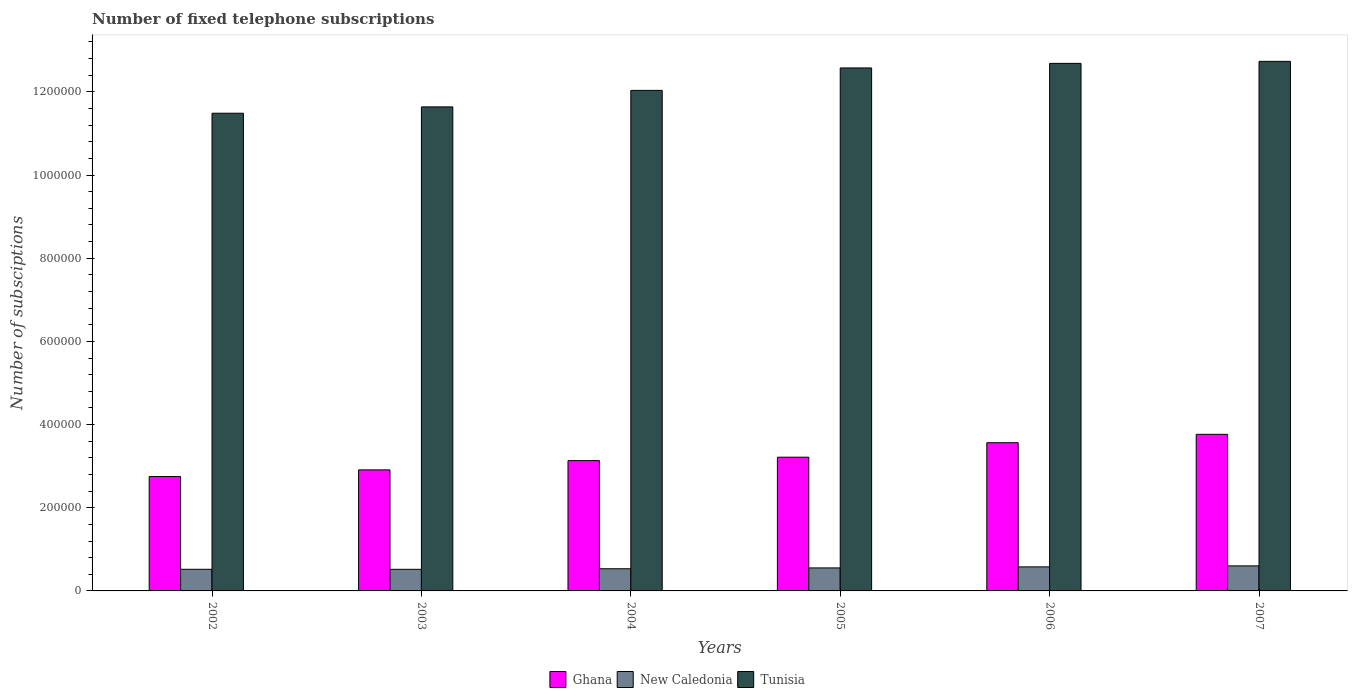How many different coloured bars are there?
Offer a very short reply. 3. Are the number of bars per tick equal to the number of legend labels?
Provide a short and direct response. Yes. How many bars are there on the 6th tick from the left?
Offer a terse response. 3. How many bars are there on the 6th tick from the right?
Your answer should be very brief. 3. What is the number of fixed telephone subscriptions in Ghana in 2003?
Your answer should be very brief. 2.91e+05. Across all years, what is the maximum number of fixed telephone subscriptions in New Caledonia?
Keep it short and to the point. 6.02e+04. Across all years, what is the minimum number of fixed telephone subscriptions in Ghana?
Provide a short and direct response. 2.75e+05. In which year was the number of fixed telephone subscriptions in New Caledonia maximum?
Your answer should be compact. 2007. What is the total number of fixed telephone subscriptions in New Caledonia in the graph?
Your answer should be compact. 3.31e+05. What is the difference between the number of fixed telephone subscriptions in New Caledonia in 2002 and that in 2005?
Offer a very short reply. -3310. What is the difference between the number of fixed telephone subscriptions in New Caledonia in 2003 and the number of fixed telephone subscriptions in Tunisia in 2002?
Provide a short and direct response. -1.10e+06. What is the average number of fixed telephone subscriptions in New Caledonia per year?
Your answer should be very brief. 5.51e+04. In the year 2005, what is the difference between the number of fixed telephone subscriptions in Tunisia and number of fixed telephone subscriptions in New Caledonia?
Make the answer very short. 1.20e+06. What is the ratio of the number of fixed telephone subscriptions in Tunisia in 2005 to that in 2006?
Give a very brief answer. 0.99. Is the difference between the number of fixed telephone subscriptions in Tunisia in 2004 and 2006 greater than the difference between the number of fixed telephone subscriptions in New Caledonia in 2004 and 2006?
Make the answer very short. No. What is the difference between the highest and the second highest number of fixed telephone subscriptions in New Caledonia?
Your answer should be compact. 2409. What is the difference between the highest and the lowest number of fixed telephone subscriptions in New Caledonia?
Provide a succinct answer. 8281. In how many years, is the number of fixed telephone subscriptions in New Caledonia greater than the average number of fixed telephone subscriptions in New Caledonia taken over all years?
Ensure brevity in your answer.  3. What does the 2nd bar from the right in 2007 represents?
Provide a succinct answer. New Caledonia. Is it the case that in every year, the sum of the number of fixed telephone subscriptions in Tunisia and number of fixed telephone subscriptions in Ghana is greater than the number of fixed telephone subscriptions in New Caledonia?
Your answer should be very brief. Yes. Are all the bars in the graph horizontal?
Provide a short and direct response. No. How are the legend labels stacked?
Give a very brief answer. Horizontal. What is the title of the graph?
Offer a very short reply. Number of fixed telephone subscriptions. Does "Iran" appear as one of the legend labels in the graph?
Offer a very short reply. No. What is the label or title of the Y-axis?
Offer a very short reply. Number of subsciptions. What is the Number of subsciptions in Ghana in 2002?
Your answer should be compact. 2.75e+05. What is the Number of subsciptions of New Caledonia in 2002?
Offer a terse response. 5.20e+04. What is the Number of subsciptions in Tunisia in 2002?
Keep it short and to the point. 1.15e+06. What is the Number of subsciptions of Ghana in 2003?
Give a very brief answer. 2.91e+05. What is the Number of subsciptions of New Caledonia in 2003?
Provide a succinct answer. 5.19e+04. What is the Number of subsciptions of Tunisia in 2003?
Provide a succinct answer. 1.16e+06. What is the Number of subsciptions in Ghana in 2004?
Ensure brevity in your answer.  3.13e+05. What is the Number of subsciptions in New Caledonia in 2004?
Your answer should be compact. 5.33e+04. What is the Number of subsciptions in Tunisia in 2004?
Your response must be concise. 1.20e+06. What is the Number of subsciptions of Ghana in 2005?
Keep it short and to the point. 3.22e+05. What is the Number of subsciptions of New Caledonia in 2005?
Ensure brevity in your answer.  5.53e+04. What is the Number of subsciptions of Tunisia in 2005?
Offer a very short reply. 1.26e+06. What is the Number of subsciptions of Ghana in 2006?
Provide a short and direct response. 3.56e+05. What is the Number of subsciptions in New Caledonia in 2006?
Provide a short and direct response. 5.78e+04. What is the Number of subsciptions of Tunisia in 2006?
Your response must be concise. 1.27e+06. What is the Number of subsciptions in Ghana in 2007?
Your answer should be very brief. 3.77e+05. What is the Number of subsciptions of New Caledonia in 2007?
Your answer should be compact. 6.02e+04. What is the Number of subsciptions in Tunisia in 2007?
Make the answer very short. 1.27e+06. Across all years, what is the maximum Number of subsciptions of Ghana?
Offer a terse response. 3.77e+05. Across all years, what is the maximum Number of subsciptions of New Caledonia?
Provide a short and direct response. 6.02e+04. Across all years, what is the maximum Number of subsciptions of Tunisia?
Offer a terse response. 1.27e+06. Across all years, what is the minimum Number of subsciptions of Ghana?
Make the answer very short. 2.75e+05. Across all years, what is the minimum Number of subsciptions in New Caledonia?
Offer a very short reply. 5.19e+04. Across all years, what is the minimum Number of subsciptions of Tunisia?
Offer a terse response. 1.15e+06. What is the total Number of subsciptions in Ghana in the graph?
Your response must be concise. 1.93e+06. What is the total Number of subsciptions of New Caledonia in the graph?
Offer a terse response. 3.31e+05. What is the total Number of subsciptions of Tunisia in the graph?
Offer a terse response. 7.32e+06. What is the difference between the Number of subsciptions of Ghana in 2002 and that in 2003?
Offer a terse response. -1.60e+04. What is the difference between the Number of subsciptions of New Caledonia in 2002 and that in 2003?
Offer a very short reply. 72. What is the difference between the Number of subsciptions of Tunisia in 2002 and that in 2003?
Offer a terse response. -1.53e+04. What is the difference between the Number of subsciptions of Ghana in 2002 and that in 2004?
Your response must be concise. -3.83e+04. What is the difference between the Number of subsciptions of New Caledonia in 2002 and that in 2004?
Ensure brevity in your answer.  -1306. What is the difference between the Number of subsciptions in Tunisia in 2002 and that in 2004?
Make the answer very short. -5.49e+04. What is the difference between the Number of subsciptions of Ghana in 2002 and that in 2005?
Keep it short and to the point. -4.65e+04. What is the difference between the Number of subsciptions in New Caledonia in 2002 and that in 2005?
Keep it short and to the point. -3310. What is the difference between the Number of subsciptions in Tunisia in 2002 and that in 2005?
Offer a terse response. -1.09e+05. What is the difference between the Number of subsciptions of Ghana in 2002 and that in 2006?
Your response must be concise. -8.13e+04. What is the difference between the Number of subsciptions of New Caledonia in 2002 and that in 2006?
Provide a succinct answer. -5800. What is the difference between the Number of subsciptions of Tunisia in 2002 and that in 2006?
Your response must be concise. -1.20e+05. What is the difference between the Number of subsciptions of Ghana in 2002 and that in 2007?
Offer a terse response. -1.01e+05. What is the difference between the Number of subsciptions of New Caledonia in 2002 and that in 2007?
Offer a terse response. -8209. What is the difference between the Number of subsciptions of Tunisia in 2002 and that in 2007?
Your answer should be compact. -1.25e+05. What is the difference between the Number of subsciptions of Ghana in 2003 and that in 2004?
Your response must be concise. -2.23e+04. What is the difference between the Number of subsciptions in New Caledonia in 2003 and that in 2004?
Give a very brief answer. -1378. What is the difference between the Number of subsciptions of Tunisia in 2003 and that in 2004?
Make the answer very short. -3.97e+04. What is the difference between the Number of subsciptions in Ghana in 2003 and that in 2005?
Ensure brevity in your answer.  -3.05e+04. What is the difference between the Number of subsciptions of New Caledonia in 2003 and that in 2005?
Provide a short and direct response. -3382. What is the difference between the Number of subsciptions of Tunisia in 2003 and that in 2005?
Offer a terse response. -9.36e+04. What is the difference between the Number of subsciptions in Ghana in 2003 and that in 2006?
Keep it short and to the point. -6.53e+04. What is the difference between the Number of subsciptions in New Caledonia in 2003 and that in 2006?
Provide a short and direct response. -5872. What is the difference between the Number of subsciptions in Tunisia in 2003 and that in 2006?
Your answer should be compact. -1.05e+05. What is the difference between the Number of subsciptions in Ghana in 2003 and that in 2007?
Your answer should be very brief. -8.55e+04. What is the difference between the Number of subsciptions of New Caledonia in 2003 and that in 2007?
Offer a terse response. -8281. What is the difference between the Number of subsciptions of Tunisia in 2003 and that in 2007?
Keep it short and to the point. -1.09e+05. What is the difference between the Number of subsciptions of Ghana in 2004 and that in 2005?
Ensure brevity in your answer.  -8200. What is the difference between the Number of subsciptions in New Caledonia in 2004 and that in 2005?
Make the answer very short. -2004. What is the difference between the Number of subsciptions of Tunisia in 2004 and that in 2005?
Offer a very short reply. -5.39e+04. What is the difference between the Number of subsciptions of Ghana in 2004 and that in 2006?
Ensure brevity in your answer.  -4.30e+04. What is the difference between the Number of subsciptions of New Caledonia in 2004 and that in 2006?
Provide a short and direct response. -4494. What is the difference between the Number of subsciptions of Tunisia in 2004 and that in 2006?
Your answer should be compact. -6.49e+04. What is the difference between the Number of subsciptions of Ghana in 2004 and that in 2007?
Offer a very short reply. -6.32e+04. What is the difference between the Number of subsciptions of New Caledonia in 2004 and that in 2007?
Give a very brief answer. -6903. What is the difference between the Number of subsciptions in Tunisia in 2004 and that in 2007?
Provide a succinct answer. -6.98e+04. What is the difference between the Number of subsciptions of Ghana in 2005 and that in 2006?
Your response must be concise. -3.48e+04. What is the difference between the Number of subsciptions in New Caledonia in 2005 and that in 2006?
Make the answer very short. -2490. What is the difference between the Number of subsciptions in Tunisia in 2005 and that in 2006?
Ensure brevity in your answer.  -1.10e+04. What is the difference between the Number of subsciptions of Ghana in 2005 and that in 2007?
Give a very brief answer. -5.50e+04. What is the difference between the Number of subsciptions in New Caledonia in 2005 and that in 2007?
Keep it short and to the point. -4899. What is the difference between the Number of subsciptions of Tunisia in 2005 and that in 2007?
Offer a terse response. -1.59e+04. What is the difference between the Number of subsciptions in Ghana in 2006 and that in 2007?
Give a very brief answer. -2.02e+04. What is the difference between the Number of subsciptions of New Caledonia in 2006 and that in 2007?
Keep it short and to the point. -2409. What is the difference between the Number of subsciptions in Tunisia in 2006 and that in 2007?
Make the answer very short. -4870. What is the difference between the Number of subsciptions of Ghana in 2002 and the Number of subsciptions of New Caledonia in 2003?
Give a very brief answer. 2.23e+05. What is the difference between the Number of subsciptions of Ghana in 2002 and the Number of subsciptions of Tunisia in 2003?
Make the answer very short. -8.89e+05. What is the difference between the Number of subsciptions of New Caledonia in 2002 and the Number of subsciptions of Tunisia in 2003?
Make the answer very short. -1.11e+06. What is the difference between the Number of subsciptions in Ghana in 2002 and the Number of subsciptions in New Caledonia in 2004?
Provide a short and direct response. 2.22e+05. What is the difference between the Number of subsciptions of Ghana in 2002 and the Number of subsciptions of Tunisia in 2004?
Provide a short and direct response. -9.28e+05. What is the difference between the Number of subsciptions in New Caledonia in 2002 and the Number of subsciptions in Tunisia in 2004?
Your answer should be compact. -1.15e+06. What is the difference between the Number of subsciptions in Ghana in 2002 and the Number of subsciptions in New Caledonia in 2005?
Offer a terse response. 2.20e+05. What is the difference between the Number of subsciptions in Ghana in 2002 and the Number of subsciptions in Tunisia in 2005?
Offer a terse response. -9.82e+05. What is the difference between the Number of subsciptions in New Caledonia in 2002 and the Number of subsciptions in Tunisia in 2005?
Your answer should be compact. -1.21e+06. What is the difference between the Number of subsciptions of Ghana in 2002 and the Number of subsciptions of New Caledonia in 2006?
Your answer should be compact. 2.17e+05. What is the difference between the Number of subsciptions of Ghana in 2002 and the Number of subsciptions of Tunisia in 2006?
Give a very brief answer. -9.93e+05. What is the difference between the Number of subsciptions in New Caledonia in 2002 and the Number of subsciptions in Tunisia in 2006?
Keep it short and to the point. -1.22e+06. What is the difference between the Number of subsciptions in Ghana in 2002 and the Number of subsciptions in New Caledonia in 2007?
Keep it short and to the point. 2.15e+05. What is the difference between the Number of subsciptions in Ghana in 2002 and the Number of subsciptions in Tunisia in 2007?
Provide a short and direct response. -9.98e+05. What is the difference between the Number of subsciptions of New Caledonia in 2002 and the Number of subsciptions of Tunisia in 2007?
Your answer should be compact. -1.22e+06. What is the difference between the Number of subsciptions in Ghana in 2003 and the Number of subsciptions in New Caledonia in 2004?
Your answer should be very brief. 2.38e+05. What is the difference between the Number of subsciptions in Ghana in 2003 and the Number of subsciptions in Tunisia in 2004?
Your answer should be very brief. -9.12e+05. What is the difference between the Number of subsciptions of New Caledonia in 2003 and the Number of subsciptions of Tunisia in 2004?
Offer a very short reply. -1.15e+06. What is the difference between the Number of subsciptions in Ghana in 2003 and the Number of subsciptions in New Caledonia in 2005?
Give a very brief answer. 2.36e+05. What is the difference between the Number of subsciptions of Ghana in 2003 and the Number of subsciptions of Tunisia in 2005?
Provide a short and direct response. -9.66e+05. What is the difference between the Number of subsciptions of New Caledonia in 2003 and the Number of subsciptions of Tunisia in 2005?
Offer a terse response. -1.21e+06. What is the difference between the Number of subsciptions in Ghana in 2003 and the Number of subsciptions in New Caledonia in 2006?
Offer a very short reply. 2.33e+05. What is the difference between the Number of subsciptions in Ghana in 2003 and the Number of subsciptions in Tunisia in 2006?
Offer a terse response. -9.77e+05. What is the difference between the Number of subsciptions in New Caledonia in 2003 and the Number of subsciptions in Tunisia in 2006?
Your response must be concise. -1.22e+06. What is the difference between the Number of subsciptions in Ghana in 2003 and the Number of subsciptions in New Caledonia in 2007?
Give a very brief answer. 2.31e+05. What is the difference between the Number of subsciptions of Ghana in 2003 and the Number of subsciptions of Tunisia in 2007?
Offer a terse response. -9.82e+05. What is the difference between the Number of subsciptions of New Caledonia in 2003 and the Number of subsciptions of Tunisia in 2007?
Provide a short and direct response. -1.22e+06. What is the difference between the Number of subsciptions of Ghana in 2004 and the Number of subsciptions of New Caledonia in 2005?
Give a very brief answer. 2.58e+05. What is the difference between the Number of subsciptions of Ghana in 2004 and the Number of subsciptions of Tunisia in 2005?
Ensure brevity in your answer.  -9.44e+05. What is the difference between the Number of subsciptions of New Caledonia in 2004 and the Number of subsciptions of Tunisia in 2005?
Offer a terse response. -1.20e+06. What is the difference between the Number of subsciptions of Ghana in 2004 and the Number of subsciptions of New Caledonia in 2006?
Your response must be concise. 2.56e+05. What is the difference between the Number of subsciptions in Ghana in 2004 and the Number of subsciptions in Tunisia in 2006?
Ensure brevity in your answer.  -9.55e+05. What is the difference between the Number of subsciptions in New Caledonia in 2004 and the Number of subsciptions in Tunisia in 2006?
Provide a succinct answer. -1.22e+06. What is the difference between the Number of subsciptions in Ghana in 2004 and the Number of subsciptions in New Caledonia in 2007?
Provide a succinct answer. 2.53e+05. What is the difference between the Number of subsciptions of Ghana in 2004 and the Number of subsciptions of Tunisia in 2007?
Give a very brief answer. -9.60e+05. What is the difference between the Number of subsciptions of New Caledonia in 2004 and the Number of subsciptions of Tunisia in 2007?
Your answer should be compact. -1.22e+06. What is the difference between the Number of subsciptions of Ghana in 2005 and the Number of subsciptions of New Caledonia in 2006?
Provide a short and direct response. 2.64e+05. What is the difference between the Number of subsciptions in Ghana in 2005 and the Number of subsciptions in Tunisia in 2006?
Make the answer very short. -9.47e+05. What is the difference between the Number of subsciptions of New Caledonia in 2005 and the Number of subsciptions of Tunisia in 2006?
Keep it short and to the point. -1.21e+06. What is the difference between the Number of subsciptions of Ghana in 2005 and the Number of subsciptions of New Caledonia in 2007?
Your answer should be compact. 2.61e+05. What is the difference between the Number of subsciptions of Ghana in 2005 and the Number of subsciptions of Tunisia in 2007?
Make the answer very short. -9.52e+05. What is the difference between the Number of subsciptions in New Caledonia in 2005 and the Number of subsciptions in Tunisia in 2007?
Provide a succinct answer. -1.22e+06. What is the difference between the Number of subsciptions in Ghana in 2006 and the Number of subsciptions in New Caledonia in 2007?
Offer a very short reply. 2.96e+05. What is the difference between the Number of subsciptions of Ghana in 2006 and the Number of subsciptions of Tunisia in 2007?
Your answer should be compact. -9.17e+05. What is the difference between the Number of subsciptions in New Caledonia in 2006 and the Number of subsciptions in Tunisia in 2007?
Your answer should be very brief. -1.22e+06. What is the average Number of subsciptions in Ghana per year?
Your answer should be compact. 3.22e+05. What is the average Number of subsciptions in New Caledonia per year?
Ensure brevity in your answer.  5.51e+04. What is the average Number of subsciptions of Tunisia per year?
Keep it short and to the point. 1.22e+06. In the year 2002, what is the difference between the Number of subsciptions of Ghana and Number of subsciptions of New Caledonia?
Make the answer very short. 2.23e+05. In the year 2002, what is the difference between the Number of subsciptions in Ghana and Number of subsciptions in Tunisia?
Your response must be concise. -8.74e+05. In the year 2002, what is the difference between the Number of subsciptions in New Caledonia and Number of subsciptions in Tunisia?
Give a very brief answer. -1.10e+06. In the year 2003, what is the difference between the Number of subsciptions of Ghana and Number of subsciptions of New Caledonia?
Provide a succinct answer. 2.39e+05. In the year 2003, what is the difference between the Number of subsciptions of Ghana and Number of subsciptions of Tunisia?
Your answer should be compact. -8.73e+05. In the year 2003, what is the difference between the Number of subsciptions in New Caledonia and Number of subsciptions in Tunisia?
Make the answer very short. -1.11e+06. In the year 2004, what is the difference between the Number of subsciptions in Ghana and Number of subsciptions in New Caledonia?
Give a very brief answer. 2.60e+05. In the year 2004, what is the difference between the Number of subsciptions in Ghana and Number of subsciptions in Tunisia?
Keep it short and to the point. -8.90e+05. In the year 2004, what is the difference between the Number of subsciptions of New Caledonia and Number of subsciptions of Tunisia?
Offer a terse response. -1.15e+06. In the year 2005, what is the difference between the Number of subsciptions of Ghana and Number of subsciptions of New Caledonia?
Your answer should be very brief. 2.66e+05. In the year 2005, what is the difference between the Number of subsciptions in Ghana and Number of subsciptions in Tunisia?
Offer a terse response. -9.36e+05. In the year 2005, what is the difference between the Number of subsciptions of New Caledonia and Number of subsciptions of Tunisia?
Your answer should be compact. -1.20e+06. In the year 2006, what is the difference between the Number of subsciptions in Ghana and Number of subsciptions in New Caledonia?
Ensure brevity in your answer.  2.99e+05. In the year 2006, what is the difference between the Number of subsciptions in Ghana and Number of subsciptions in Tunisia?
Your answer should be very brief. -9.12e+05. In the year 2006, what is the difference between the Number of subsciptions of New Caledonia and Number of subsciptions of Tunisia?
Give a very brief answer. -1.21e+06. In the year 2007, what is the difference between the Number of subsciptions of Ghana and Number of subsciptions of New Caledonia?
Offer a terse response. 3.16e+05. In the year 2007, what is the difference between the Number of subsciptions in Ghana and Number of subsciptions in Tunisia?
Ensure brevity in your answer.  -8.97e+05. In the year 2007, what is the difference between the Number of subsciptions in New Caledonia and Number of subsciptions in Tunisia?
Keep it short and to the point. -1.21e+06. What is the ratio of the Number of subsciptions in Ghana in 2002 to that in 2003?
Ensure brevity in your answer.  0.95. What is the ratio of the Number of subsciptions of New Caledonia in 2002 to that in 2003?
Keep it short and to the point. 1. What is the ratio of the Number of subsciptions of Tunisia in 2002 to that in 2003?
Your answer should be very brief. 0.99. What is the ratio of the Number of subsciptions of Ghana in 2002 to that in 2004?
Your answer should be very brief. 0.88. What is the ratio of the Number of subsciptions in New Caledonia in 2002 to that in 2004?
Your response must be concise. 0.98. What is the ratio of the Number of subsciptions in Tunisia in 2002 to that in 2004?
Give a very brief answer. 0.95. What is the ratio of the Number of subsciptions of Ghana in 2002 to that in 2005?
Make the answer very short. 0.86. What is the ratio of the Number of subsciptions in New Caledonia in 2002 to that in 2005?
Provide a short and direct response. 0.94. What is the ratio of the Number of subsciptions of Tunisia in 2002 to that in 2005?
Give a very brief answer. 0.91. What is the ratio of the Number of subsciptions in Ghana in 2002 to that in 2006?
Offer a very short reply. 0.77. What is the ratio of the Number of subsciptions of New Caledonia in 2002 to that in 2006?
Provide a succinct answer. 0.9. What is the ratio of the Number of subsciptions in Tunisia in 2002 to that in 2006?
Make the answer very short. 0.91. What is the ratio of the Number of subsciptions of Ghana in 2002 to that in 2007?
Provide a short and direct response. 0.73. What is the ratio of the Number of subsciptions in New Caledonia in 2002 to that in 2007?
Make the answer very short. 0.86. What is the ratio of the Number of subsciptions of Tunisia in 2002 to that in 2007?
Make the answer very short. 0.9. What is the ratio of the Number of subsciptions of Ghana in 2003 to that in 2004?
Provide a succinct answer. 0.93. What is the ratio of the Number of subsciptions in New Caledonia in 2003 to that in 2004?
Your answer should be very brief. 0.97. What is the ratio of the Number of subsciptions of Ghana in 2003 to that in 2005?
Your response must be concise. 0.91. What is the ratio of the Number of subsciptions in New Caledonia in 2003 to that in 2005?
Make the answer very short. 0.94. What is the ratio of the Number of subsciptions in Tunisia in 2003 to that in 2005?
Ensure brevity in your answer.  0.93. What is the ratio of the Number of subsciptions in Ghana in 2003 to that in 2006?
Make the answer very short. 0.82. What is the ratio of the Number of subsciptions in New Caledonia in 2003 to that in 2006?
Ensure brevity in your answer.  0.9. What is the ratio of the Number of subsciptions of Tunisia in 2003 to that in 2006?
Make the answer very short. 0.92. What is the ratio of the Number of subsciptions of Ghana in 2003 to that in 2007?
Provide a succinct answer. 0.77. What is the ratio of the Number of subsciptions of New Caledonia in 2003 to that in 2007?
Your answer should be very brief. 0.86. What is the ratio of the Number of subsciptions of Tunisia in 2003 to that in 2007?
Ensure brevity in your answer.  0.91. What is the ratio of the Number of subsciptions in Ghana in 2004 to that in 2005?
Your answer should be compact. 0.97. What is the ratio of the Number of subsciptions of New Caledonia in 2004 to that in 2005?
Keep it short and to the point. 0.96. What is the ratio of the Number of subsciptions in Tunisia in 2004 to that in 2005?
Offer a terse response. 0.96. What is the ratio of the Number of subsciptions of Ghana in 2004 to that in 2006?
Make the answer very short. 0.88. What is the ratio of the Number of subsciptions in New Caledonia in 2004 to that in 2006?
Make the answer very short. 0.92. What is the ratio of the Number of subsciptions of Tunisia in 2004 to that in 2006?
Your answer should be very brief. 0.95. What is the ratio of the Number of subsciptions in Ghana in 2004 to that in 2007?
Your answer should be compact. 0.83. What is the ratio of the Number of subsciptions of New Caledonia in 2004 to that in 2007?
Provide a short and direct response. 0.89. What is the ratio of the Number of subsciptions of Tunisia in 2004 to that in 2007?
Your answer should be compact. 0.95. What is the ratio of the Number of subsciptions in Ghana in 2005 to that in 2006?
Your response must be concise. 0.9. What is the ratio of the Number of subsciptions in New Caledonia in 2005 to that in 2006?
Give a very brief answer. 0.96. What is the ratio of the Number of subsciptions in Ghana in 2005 to that in 2007?
Ensure brevity in your answer.  0.85. What is the ratio of the Number of subsciptions of New Caledonia in 2005 to that in 2007?
Provide a succinct answer. 0.92. What is the ratio of the Number of subsciptions in Tunisia in 2005 to that in 2007?
Offer a terse response. 0.99. What is the ratio of the Number of subsciptions in Ghana in 2006 to that in 2007?
Provide a short and direct response. 0.95. What is the ratio of the Number of subsciptions in New Caledonia in 2006 to that in 2007?
Keep it short and to the point. 0.96. What is the difference between the highest and the second highest Number of subsciptions in Ghana?
Keep it short and to the point. 2.02e+04. What is the difference between the highest and the second highest Number of subsciptions in New Caledonia?
Offer a terse response. 2409. What is the difference between the highest and the second highest Number of subsciptions of Tunisia?
Offer a very short reply. 4870. What is the difference between the highest and the lowest Number of subsciptions of Ghana?
Make the answer very short. 1.01e+05. What is the difference between the highest and the lowest Number of subsciptions in New Caledonia?
Offer a terse response. 8281. What is the difference between the highest and the lowest Number of subsciptions of Tunisia?
Your response must be concise. 1.25e+05. 